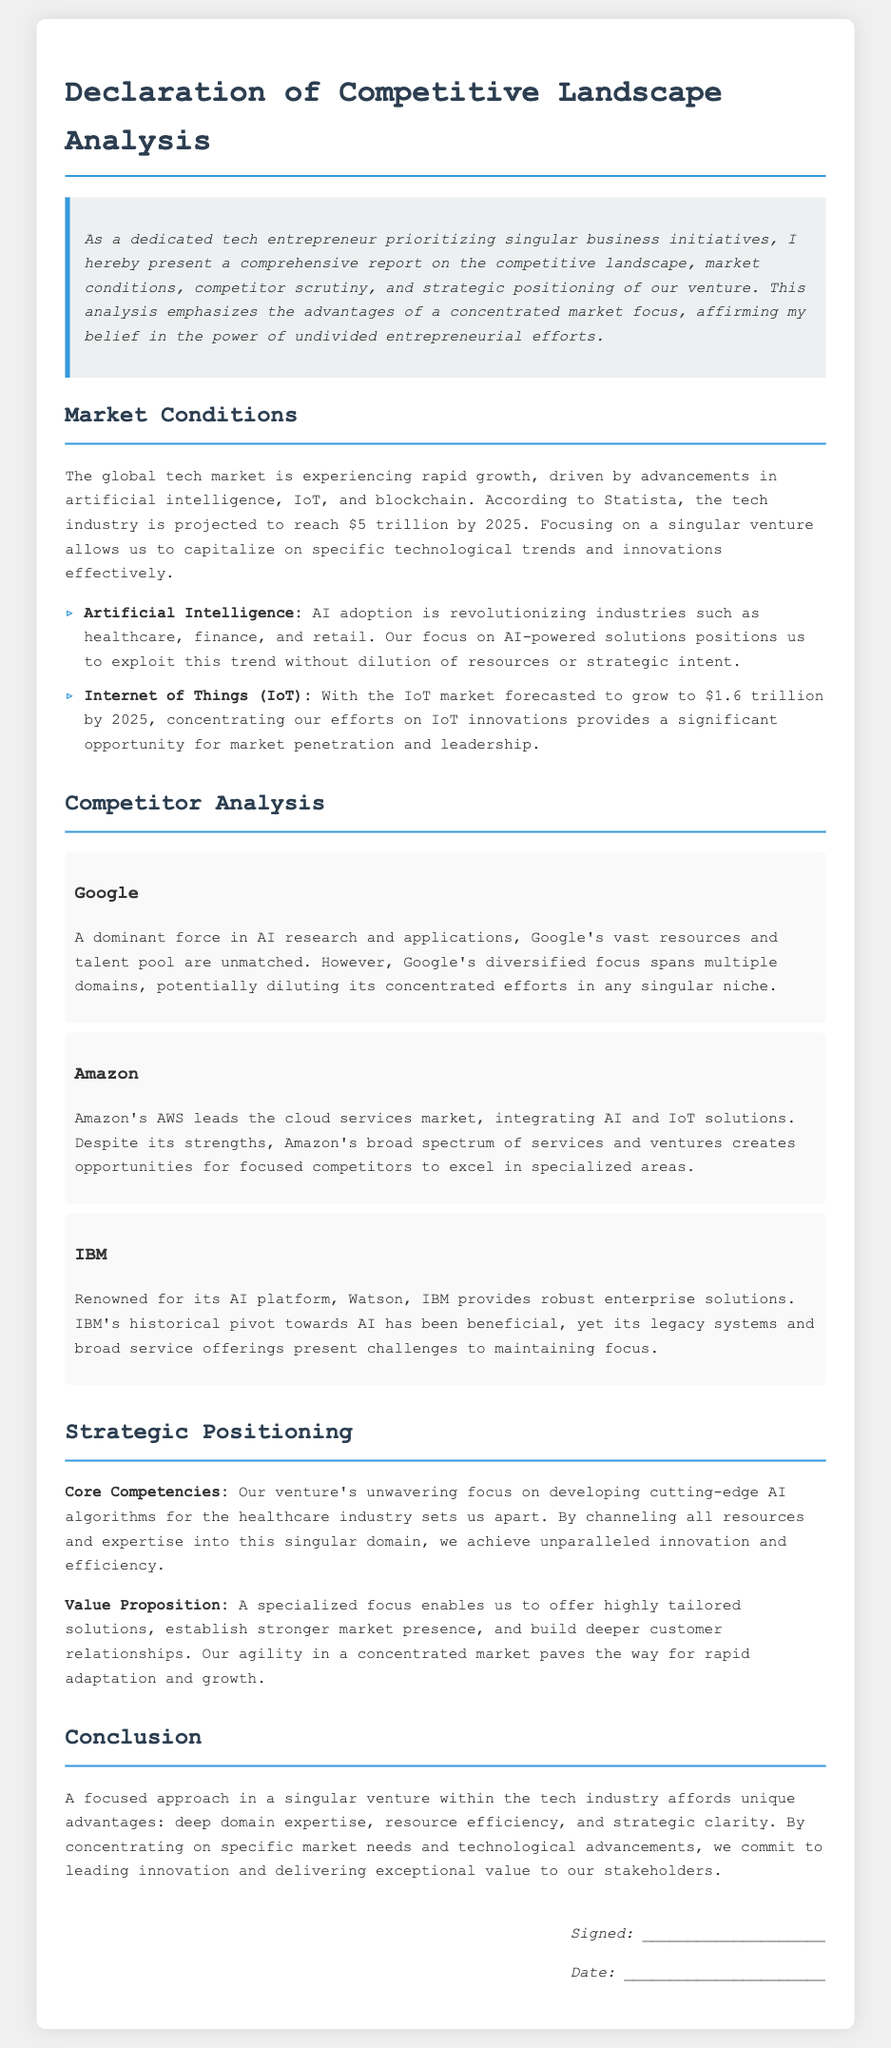What is the projected value of the tech industry by 2025? According to the document, the tech industry is projected to reach $5 trillion by 2025.
Answer: $5 trillion What market is forecasted to grow to $1.6 trillion by 2025? The document states that the IoT market is forecasted to grow to $1.6 trillion by 2025.
Answer: IoT market Who provides robust enterprise solutions with its AI platform called Watson? The document mentions IBM as the company renowned for its AI platform, Watson.
Answer: IBM What is the core competency of the venture? The core competency highlighted in the document is developing cutting-edge AI algorithms for the healthcare industry.
Answer: AI algorithms for healthcare What is the value proposition mentioned in the analysis? The value proposition discussed in the document is that a specialized focus enables offering highly tailored solutions.
Answer: Highly tailored solutions What is emphasized as an advantage of focusing on a singular venture? The document emphasizes that a focused approach affords unique advantages like deep domain expertise.
Answer: Deep domain expertise What does the declaration affirm about entrepreneurial efforts? The declaration affirms the belief in the power of undivided entrepreneurial efforts.
Answer: Undivided entrepreneurial efforts What date and signature are required at the end of the document? The document requires a signature and date at the end, which are left blank.
Answer: Signature and date 